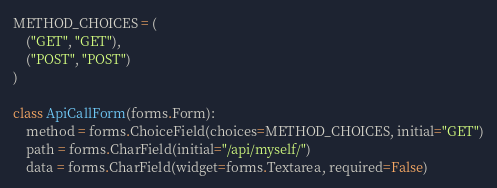Convert code to text. <code><loc_0><loc_0><loc_500><loc_500><_Python_>METHOD_CHOICES = (
    ("GET", "GET"),
    ("POST", "POST")
)

class ApiCallForm(forms.Form):
    method = forms.ChoiceField(choices=METHOD_CHOICES, initial="GET")
    path = forms.CharField(initial="/api/myself/")
    data = forms.CharField(widget=forms.Textarea, required=False)
</code> 